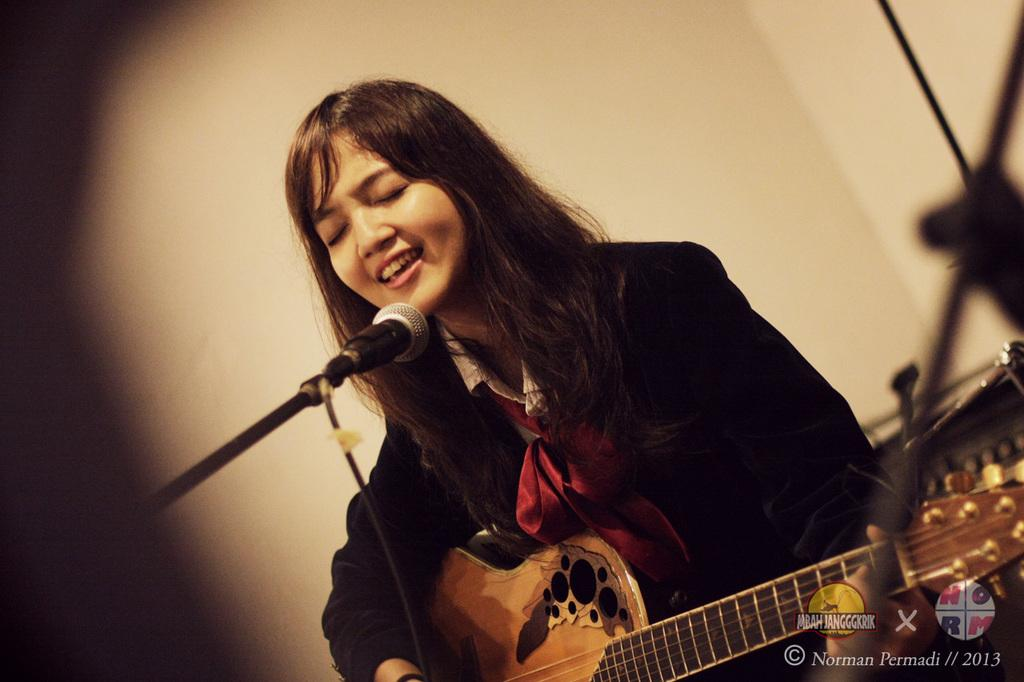What is the main subject of the image? The main subject of the image is a woman. What is the woman holding in the image? The woman is holding a guitar. What activity is the woman engaged in? The woman is singing on a microphone. What type of gate can be seen in the image? There is no gate present in the image. How many ladybugs can be seen on the woman's guitar in the image? There are no ladybugs present in the image. 